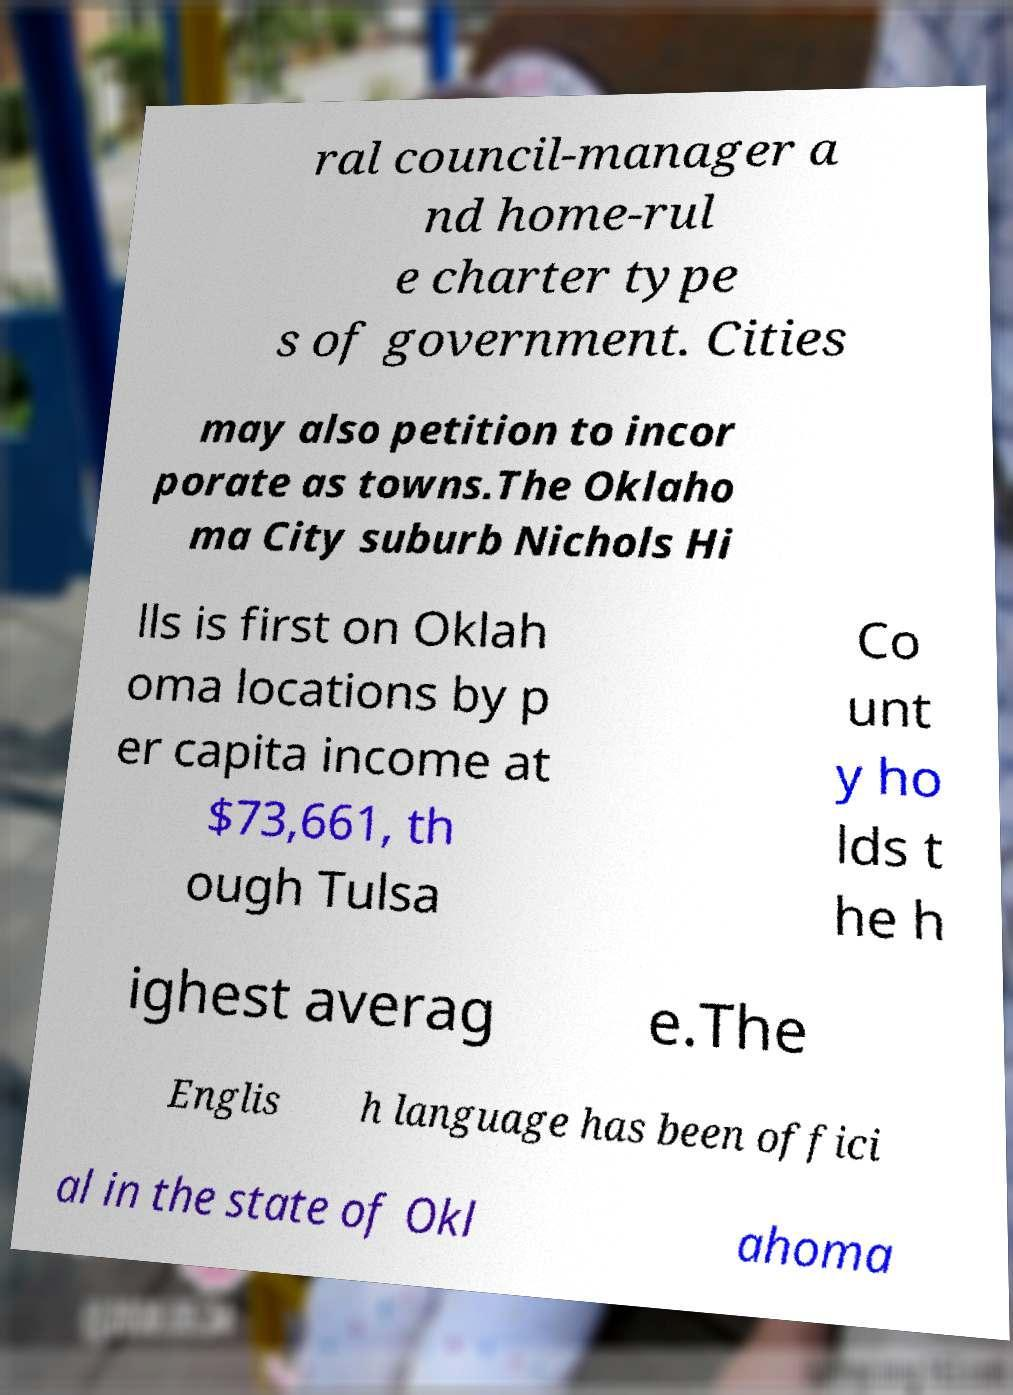I need the written content from this picture converted into text. Can you do that? ral council-manager a nd home-rul e charter type s of government. Cities may also petition to incor porate as towns.The Oklaho ma City suburb Nichols Hi lls is first on Oklah oma locations by p er capita income at $73,661, th ough Tulsa Co unt y ho lds t he h ighest averag e.The Englis h language has been offici al in the state of Okl ahoma 